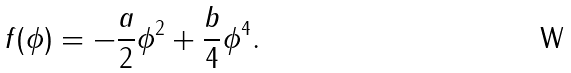Convert formula to latex. <formula><loc_0><loc_0><loc_500><loc_500>f ( \phi ) = - \frac { a } { 2 } \phi ^ { 2 } + \frac { b } { 4 } \phi ^ { 4 } .</formula> 